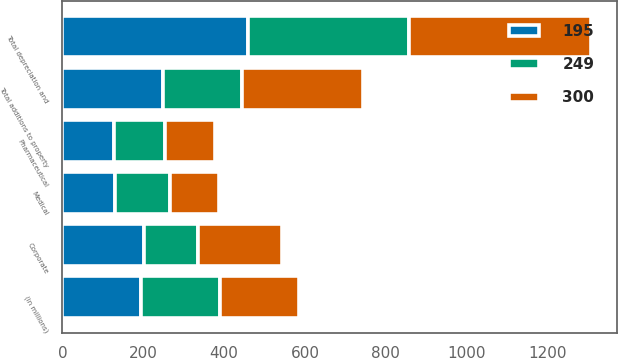<chart> <loc_0><loc_0><loc_500><loc_500><stacked_bar_chart><ecel><fcel>(in millions)<fcel>Pharmaceutical<fcel>Medical<fcel>Corporate<fcel>Total depreciation and<fcel>Total additions to property<nl><fcel>300<fcel>195<fcel>124<fcel>119<fcel>208<fcel>451<fcel>300<nl><fcel>195<fcel>195<fcel>128<fcel>130<fcel>201<fcel>459<fcel>249<nl><fcel>249<fcel>195<fcel>125<fcel>137<fcel>135<fcel>397<fcel>195<nl></chart> 